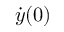<formula> <loc_0><loc_0><loc_500><loc_500>\dot { y } ( 0 )</formula> 